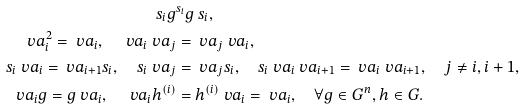Convert formula to latex. <formula><loc_0><loc_0><loc_500><loc_500>s _ { i } g & ^ { s _ { i } } g \, s _ { i } , \\ \ v a _ { i } ^ { 2 } = \ v a _ { i } , \quad \ v a _ { i } \ v a _ { j } & = \ v a _ { j } \ v a _ { i } , \\ s _ { i } \ v a _ { i } = \ v a _ { i + 1 } s _ { i } , \quad s _ { i } \ v a _ { j } & = \ v a _ { j } s _ { i } , \quad s _ { i } \ v a _ { i } \ v a _ { i + 1 } = \ v a _ { i } \ v a _ { i + 1 } , \quad j \neq i , i + 1 , \\ \quad \ v a _ { i } g = g \ v a _ { i } , \quad \ v a _ { i } h ^ { ( i ) } & = h ^ { ( i ) } \ v a _ { i } = \ v a _ { i } , \quad \forall g \in G ^ { n } , h \in G .</formula> 